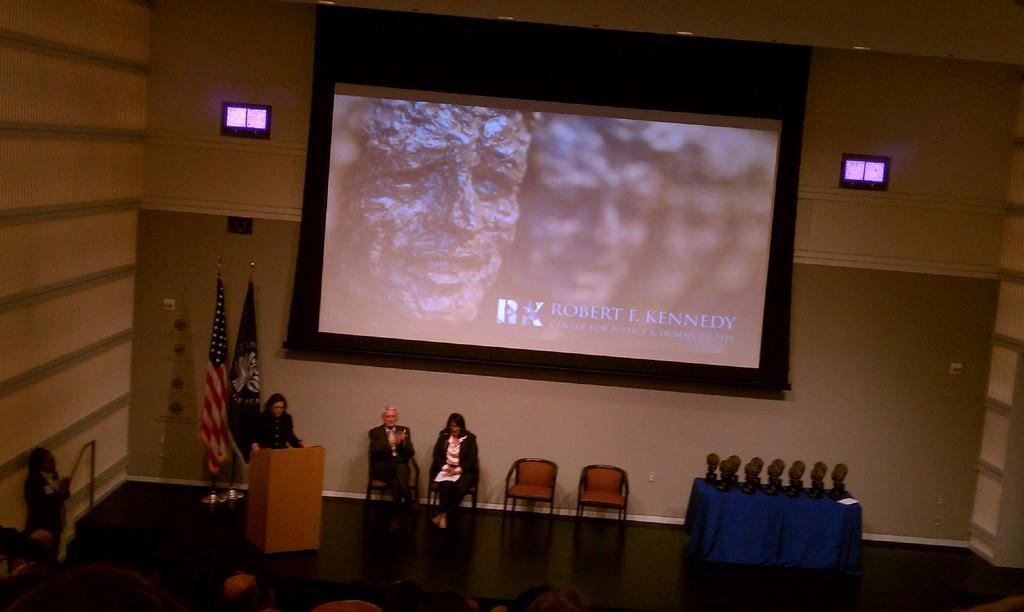Could you give a brief overview of what you see in this image? At the bottom of the picture, we see the heads of the people. In the middle, we see a man and the women are sitting on the chairs. Beside them, we see two empty chairs. Beside them, we see a woman is standing. In front of her, we see a podium and I think she is talking. Behind her, we see the flags in white, red, blue and black color. Behind that, we see a wall. In the background, we see a projector screen which is displaying the image of men. On the right side, we see a wall in white and grey color. We see a table which is covered with a blue color sheet. We see the objects in black color are placed on the table. In the left bottom, we see a person is standing. 